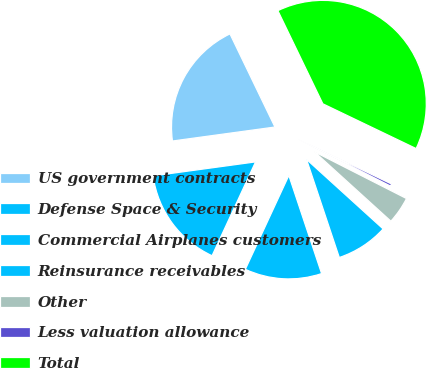Convert chart to OTSL. <chart><loc_0><loc_0><loc_500><loc_500><pie_chart><fcel>US government contracts<fcel>Defense Space & Security<fcel>Commercial Airplanes customers<fcel>Reinsurance receivables<fcel>Other<fcel>Less valuation allowance<fcel>Total<nl><fcel>20.0%<fcel>15.93%<fcel>12.04%<fcel>8.14%<fcel>4.25%<fcel>0.36%<fcel>39.28%<nl></chart> 